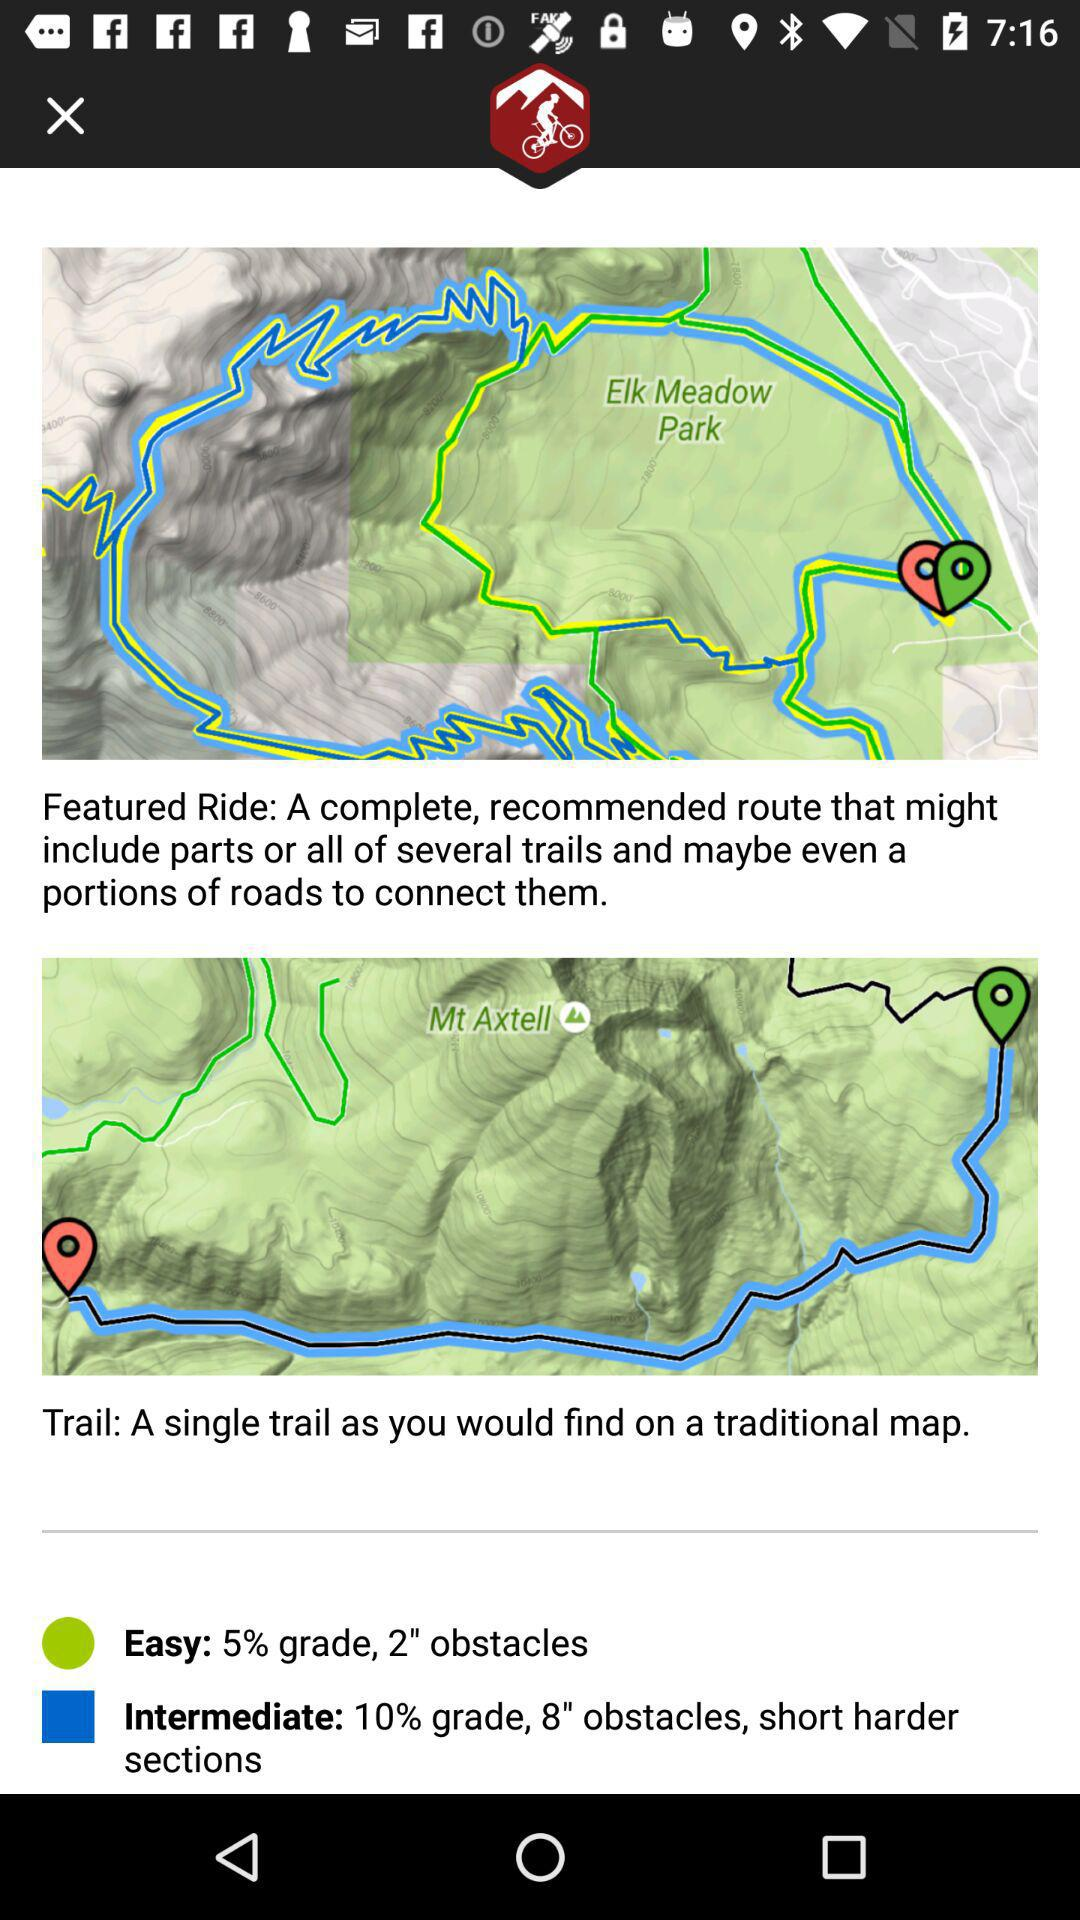What is the height of the obstacles that are there in the "Intermediate"? The height of the obstacles that are there in the "Intermediate" is 8". 